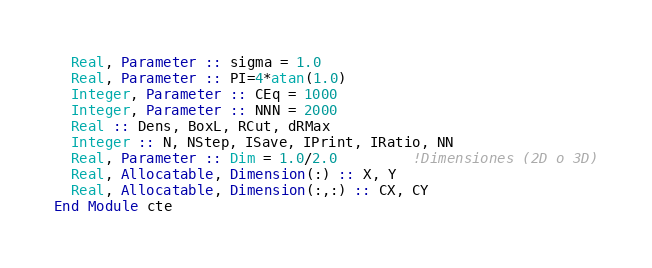Convert code to text. <code><loc_0><loc_0><loc_500><loc_500><_FORTRAN_>  Real, Parameter :: sigma = 1.0
  Real, Parameter :: PI=4*atan(1.0)
  Integer, Parameter :: CEq = 1000
  Integer, Parameter :: NNN = 2000
  Real :: Dens, BoxL, RCut, dRMax
  Integer :: N, NStep, ISave, IPrint, IRatio, NN
  Real, Parameter :: Dim = 1.0/2.0         !Dimensiones (2D o 3D)
  Real, Allocatable, Dimension(:) :: X, Y
  Real, Allocatable, Dimension(:,:) :: CX, CY
End Module cte
</code> 